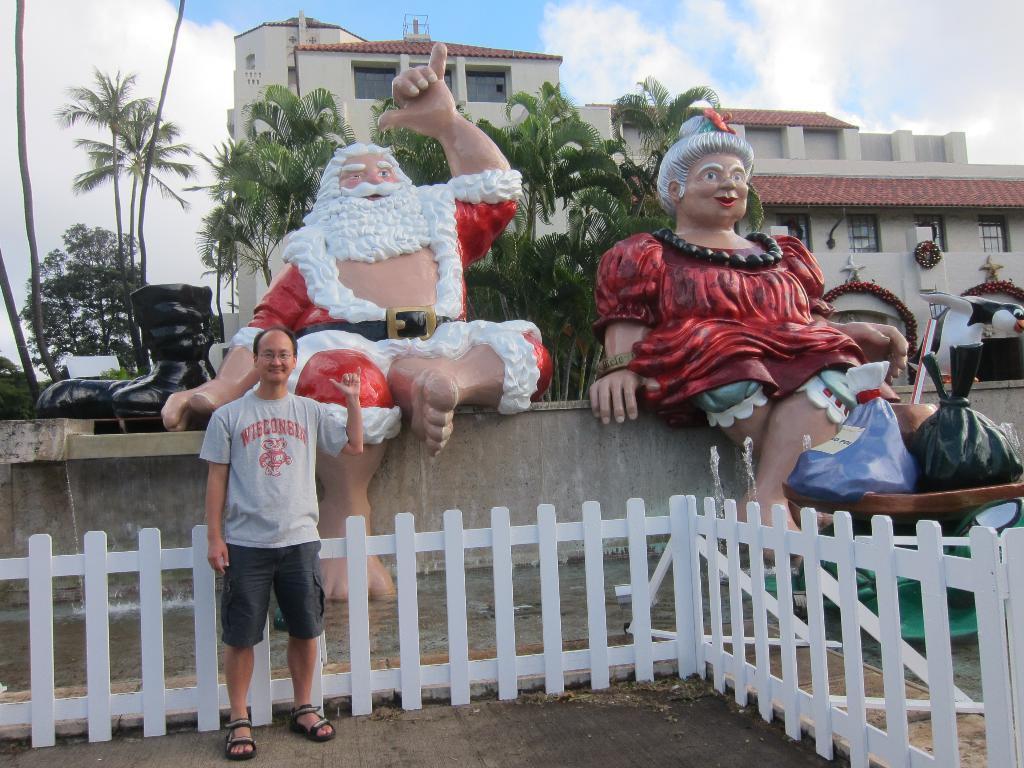Describe this image in one or two sentences. In the background we can see the clouds in the sky. We can see a building, windows and few objects. In this picture we can the statues. We can see a man standing near the fence and giving a pose. 